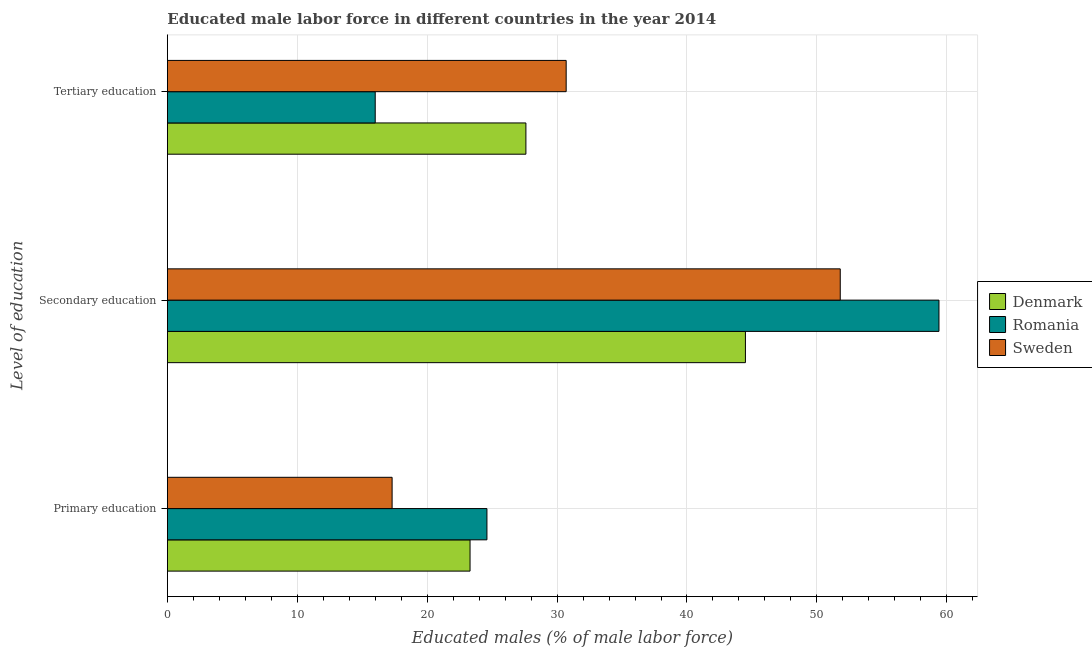How many groups of bars are there?
Keep it short and to the point. 3. Are the number of bars on each tick of the Y-axis equal?
Your answer should be compact. Yes. How many bars are there on the 1st tick from the top?
Make the answer very short. 3. What is the label of the 1st group of bars from the top?
Your answer should be very brief. Tertiary education. What is the percentage of male labor force who received primary education in Sweden?
Provide a succinct answer. 17.3. Across all countries, what is the maximum percentage of male labor force who received secondary education?
Your response must be concise. 59.4. In which country was the percentage of male labor force who received tertiary education maximum?
Keep it short and to the point. Sweden. What is the total percentage of male labor force who received secondary education in the graph?
Provide a short and direct response. 155.7. What is the difference between the percentage of male labor force who received secondary education in Romania and that in Denmark?
Keep it short and to the point. 14.9. What is the difference between the percentage of male labor force who received secondary education in Romania and the percentage of male labor force who received tertiary education in Sweden?
Offer a very short reply. 28.7. What is the average percentage of male labor force who received primary education per country?
Your answer should be very brief. 21.73. What is the difference between the percentage of male labor force who received tertiary education and percentage of male labor force who received secondary education in Denmark?
Give a very brief answer. -16.9. What is the ratio of the percentage of male labor force who received secondary education in Sweden to that in Denmark?
Provide a short and direct response. 1.16. What is the difference between the highest and the second highest percentage of male labor force who received secondary education?
Provide a short and direct response. 7.6. What is the difference between the highest and the lowest percentage of male labor force who received tertiary education?
Give a very brief answer. 14.7. Is the sum of the percentage of male labor force who received primary education in Denmark and Romania greater than the maximum percentage of male labor force who received tertiary education across all countries?
Your answer should be very brief. Yes. What does the 3rd bar from the top in Secondary education represents?
Keep it short and to the point. Denmark. How many bars are there?
Your answer should be very brief. 9. Does the graph contain any zero values?
Provide a short and direct response. No. Does the graph contain grids?
Give a very brief answer. Yes. How are the legend labels stacked?
Your answer should be very brief. Vertical. What is the title of the graph?
Offer a terse response. Educated male labor force in different countries in the year 2014. Does "Kenya" appear as one of the legend labels in the graph?
Your answer should be compact. No. What is the label or title of the X-axis?
Offer a very short reply. Educated males (% of male labor force). What is the label or title of the Y-axis?
Offer a terse response. Level of education. What is the Educated males (% of male labor force) in Denmark in Primary education?
Provide a short and direct response. 23.3. What is the Educated males (% of male labor force) of Romania in Primary education?
Your answer should be very brief. 24.6. What is the Educated males (% of male labor force) of Sweden in Primary education?
Provide a succinct answer. 17.3. What is the Educated males (% of male labor force) in Denmark in Secondary education?
Make the answer very short. 44.5. What is the Educated males (% of male labor force) in Romania in Secondary education?
Ensure brevity in your answer.  59.4. What is the Educated males (% of male labor force) in Sweden in Secondary education?
Offer a terse response. 51.8. What is the Educated males (% of male labor force) of Denmark in Tertiary education?
Give a very brief answer. 27.6. What is the Educated males (% of male labor force) in Romania in Tertiary education?
Keep it short and to the point. 16. What is the Educated males (% of male labor force) in Sweden in Tertiary education?
Make the answer very short. 30.7. Across all Level of education, what is the maximum Educated males (% of male labor force) in Denmark?
Give a very brief answer. 44.5. Across all Level of education, what is the maximum Educated males (% of male labor force) in Romania?
Your response must be concise. 59.4. Across all Level of education, what is the maximum Educated males (% of male labor force) of Sweden?
Provide a short and direct response. 51.8. Across all Level of education, what is the minimum Educated males (% of male labor force) of Denmark?
Offer a terse response. 23.3. Across all Level of education, what is the minimum Educated males (% of male labor force) in Romania?
Make the answer very short. 16. Across all Level of education, what is the minimum Educated males (% of male labor force) of Sweden?
Your response must be concise. 17.3. What is the total Educated males (% of male labor force) in Denmark in the graph?
Provide a short and direct response. 95.4. What is the total Educated males (% of male labor force) in Sweden in the graph?
Your response must be concise. 99.8. What is the difference between the Educated males (% of male labor force) of Denmark in Primary education and that in Secondary education?
Provide a short and direct response. -21.2. What is the difference between the Educated males (% of male labor force) of Romania in Primary education and that in Secondary education?
Your answer should be compact. -34.8. What is the difference between the Educated males (% of male labor force) in Sweden in Primary education and that in Secondary education?
Ensure brevity in your answer.  -34.5. What is the difference between the Educated males (% of male labor force) of Romania in Primary education and that in Tertiary education?
Ensure brevity in your answer.  8.6. What is the difference between the Educated males (% of male labor force) in Sweden in Primary education and that in Tertiary education?
Offer a terse response. -13.4. What is the difference between the Educated males (% of male labor force) of Romania in Secondary education and that in Tertiary education?
Ensure brevity in your answer.  43.4. What is the difference between the Educated males (% of male labor force) in Sweden in Secondary education and that in Tertiary education?
Make the answer very short. 21.1. What is the difference between the Educated males (% of male labor force) in Denmark in Primary education and the Educated males (% of male labor force) in Romania in Secondary education?
Provide a short and direct response. -36.1. What is the difference between the Educated males (% of male labor force) of Denmark in Primary education and the Educated males (% of male labor force) of Sweden in Secondary education?
Offer a terse response. -28.5. What is the difference between the Educated males (% of male labor force) of Romania in Primary education and the Educated males (% of male labor force) of Sweden in Secondary education?
Your response must be concise. -27.2. What is the difference between the Educated males (% of male labor force) in Denmark in Primary education and the Educated males (% of male labor force) in Romania in Tertiary education?
Your response must be concise. 7.3. What is the difference between the Educated males (% of male labor force) in Denmark in Secondary education and the Educated males (% of male labor force) in Sweden in Tertiary education?
Your answer should be very brief. 13.8. What is the difference between the Educated males (% of male labor force) in Romania in Secondary education and the Educated males (% of male labor force) in Sweden in Tertiary education?
Offer a very short reply. 28.7. What is the average Educated males (% of male labor force) in Denmark per Level of education?
Keep it short and to the point. 31.8. What is the average Educated males (% of male labor force) of Romania per Level of education?
Your answer should be compact. 33.33. What is the average Educated males (% of male labor force) in Sweden per Level of education?
Give a very brief answer. 33.27. What is the difference between the Educated males (% of male labor force) of Denmark and Educated males (% of male labor force) of Romania in Primary education?
Your response must be concise. -1.3. What is the difference between the Educated males (% of male labor force) in Denmark and Educated males (% of male labor force) in Romania in Secondary education?
Provide a short and direct response. -14.9. What is the difference between the Educated males (% of male labor force) of Denmark and Educated males (% of male labor force) of Sweden in Secondary education?
Provide a short and direct response. -7.3. What is the difference between the Educated males (% of male labor force) of Romania and Educated males (% of male labor force) of Sweden in Secondary education?
Give a very brief answer. 7.6. What is the difference between the Educated males (% of male labor force) of Denmark and Educated males (% of male labor force) of Romania in Tertiary education?
Provide a short and direct response. 11.6. What is the difference between the Educated males (% of male labor force) in Romania and Educated males (% of male labor force) in Sweden in Tertiary education?
Your answer should be very brief. -14.7. What is the ratio of the Educated males (% of male labor force) in Denmark in Primary education to that in Secondary education?
Your answer should be compact. 0.52. What is the ratio of the Educated males (% of male labor force) in Romania in Primary education to that in Secondary education?
Your answer should be compact. 0.41. What is the ratio of the Educated males (% of male labor force) in Sweden in Primary education to that in Secondary education?
Make the answer very short. 0.33. What is the ratio of the Educated males (% of male labor force) in Denmark in Primary education to that in Tertiary education?
Provide a short and direct response. 0.84. What is the ratio of the Educated males (% of male labor force) of Romania in Primary education to that in Tertiary education?
Your answer should be very brief. 1.54. What is the ratio of the Educated males (% of male labor force) of Sweden in Primary education to that in Tertiary education?
Ensure brevity in your answer.  0.56. What is the ratio of the Educated males (% of male labor force) of Denmark in Secondary education to that in Tertiary education?
Ensure brevity in your answer.  1.61. What is the ratio of the Educated males (% of male labor force) of Romania in Secondary education to that in Tertiary education?
Your answer should be compact. 3.71. What is the ratio of the Educated males (% of male labor force) of Sweden in Secondary education to that in Tertiary education?
Provide a succinct answer. 1.69. What is the difference between the highest and the second highest Educated males (% of male labor force) of Denmark?
Provide a succinct answer. 16.9. What is the difference between the highest and the second highest Educated males (% of male labor force) of Romania?
Your answer should be compact. 34.8. What is the difference between the highest and the second highest Educated males (% of male labor force) of Sweden?
Offer a terse response. 21.1. What is the difference between the highest and the lowest Educated males (% of male labor force) in Denmark?
Provide a succinct answer. 21.2. What is the difference between the highest and the lowest Educated males (% of male labor force) of Romania?
Your response must be concise. 43.4. What is the difference between the highest and the lowest Educated males (% of male labor force) in Sweden?
Ensure brevity in your answer.  34.5. 